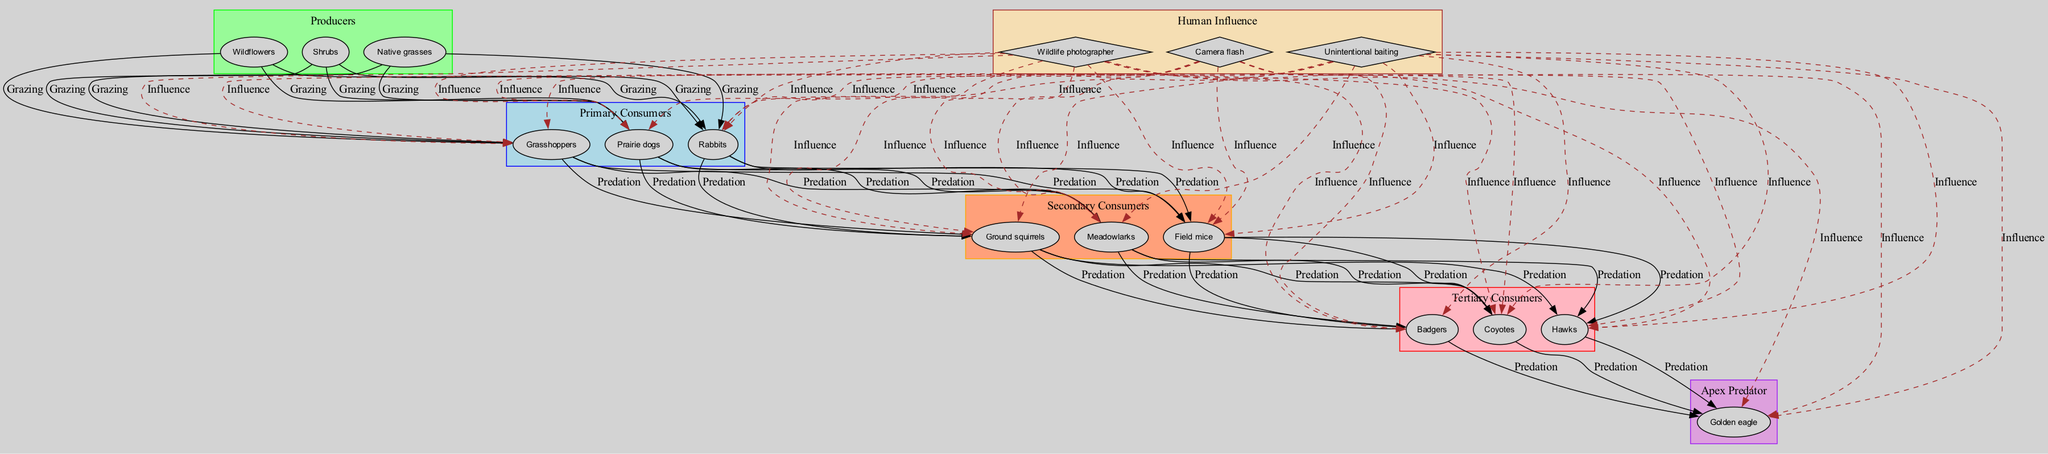What are the producers in this ecosystem? The producers listed in the diagram include native grasses, wildflowers, and shrubs. These are the first level of the food chain that generates energy through photosynthesis.
Answer: Native grasses, wildflowers, shrubs How many primary consumers are there? The diagram indicates there are three primary consumers: grasshoppers, prairie dogs, and rabbits. By counting the number of entries in that category, we determine the figure.
Answer: 3 Which secondary consumer is influenced by the wildlife photographer? The diagram shows that all secondary consumers, including field mice, meadowlarks, and ground squirrels, are influenced by the wildlife photographer. Therefore, any of these could be accurate. Here, we choose meadowlarks as an example.
Answer: Meadowlarks What type of relationship exists between primary consumers and secondary consumers? The relationship portrayed between primary and secondary consumers is "Predation". This means primary consumers are preyed upon by secondary consumers.
Answer: Predation Which apex predator is listed in the diagram? The only apex predator present in the diagram is the golden eagle, which is positioned at the top of the food chain with no other predators above it.
Answer: Golden eagle If a prairie dog is grazed by a coyote, what type of relationship is that? The relationship between a prairie dog (primary consumer) and a coyote (tertiary consumer) is also classified as "Predation", indicating that the coyote hunts the prairie dog for food.
Answer: Predation What human influence affects all levels of consumers? The diagram highlights 'wildlife photographer' as a human influence that affects all levels of consumers. This indicates that photography, alongside other factors like flash and baiting, impacts the behavior of animals at all stages of the food web.
Answer: Wildlife photographer How many types of consumers are identified in the diagram? The diagram classifies consumers into three distinct types: primary consumers, secondary consumers, and tertiary consumers. By counting these, we verify the total.
Answer: 3 What kind of influence does camera flash have on tertiary consumers? The camera flash, as a human influence, is shown to affect tertiary consumers in the diagram. It alters their behavior and possibly makes them more visible for wildlife photographers, which affects feeding patterns.
Answer: Altered feeding patterns 